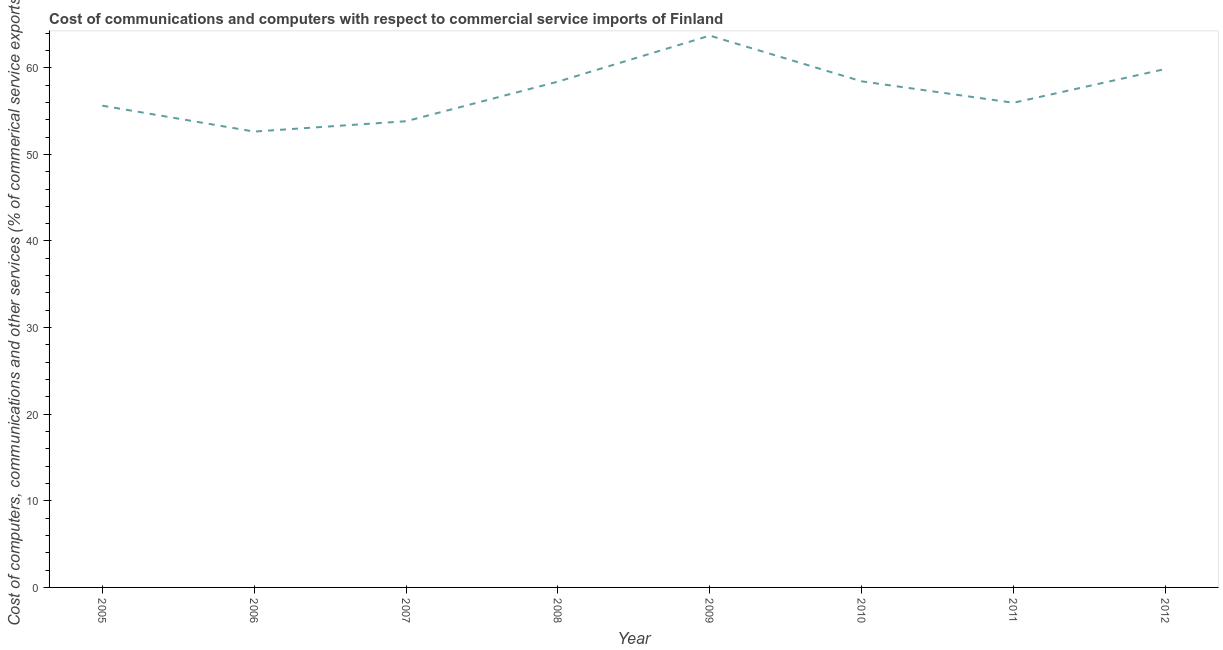What is the  computer and other services in 2006?
Give a very brief answer. 52.63. Across all years, what is the maximum cost of communications?
Keep it short and to the point. 63.71. Across all years, what is the minimum cost of communications?
Ensure brevity in your answer.  52.63. In which year was the cost of communications maximum?
Offer a very short reply. 2009. What is the sum of the  computer and other services?
Provide a short and direct response. 458.43. What is the difference between the  computer and other services in 2007 and 2008?
Provide a short and direct response. -4.57. What is the average  computer and other services per year?
Your answer should be very brief. 57.3. What is the median cost of communications?
Your answer should be very brief. 57.18. Do a majority of the years between 2011 and 2008 (inclusive) have cost of communications greater than 56 %?
Provide a succinct answer. Yes. What is the ratio of the cost of communications in 2006 to that in 2012?
Offer a very short reply. 0.88. Is the cost of communications in 2005 less than that in 2009?
Provide a succinct answer. Yes. Is the difference between the  computer and other services in 2008 and 2009 greater than the difference between any two years?
Provide a succinct answer. No. What is the difference between the highest and the second highest cost of communications?
Keep it short and to the point. 3.85. What is the difference between the highest and the lowest  computer and other services?
Your response must be concise. 11.08. Does the cost of communications monotonically increase over the years?
Your answer should be compact. No. What is the title of the graph?
Ensure brevity in your answer.  Cost of communications and computers with respect to commercial service imports of Finland. What is the label or title of the Y-axis?
Provide a succinct answer. Cost of computers, communications and other services (% of commerical service exports). What is the Cost of computers, communications and other services (% of commerical service exports) in 2005?
Provide a short and direct response. 55.62. What is the Cost of computers, communications and other services (% of commerical service exports) in 2006?
Your response must be concise. 52.63. What is the Cost of computers, communications and other services (% of commerical service exports) of 2007?
Provide a succinct answer. 53.83. What is the Cost of computers, communications and other services (% of commerical service exports) of 2008?
Provide a short and direct response. 58.4. What is the Cost of computers, communications and other services (% of commerical service exports) of 2009?
Keep it short and to the point. 63.71. What is the Cost of computers, communications and other services (% of commerical service exports) of 2010?
Keep it short and to the point. 58.43. What is the Cost of computers, communications and other services (% of commerical service exports) of 2011?
Provide a short and direct response. 55.96. What is the Cost of computers, communications and other services (% of commerical service exports) in 2012?
Provide a succinct answer. 59.86. What is the difference between the Cost of computers, communications and other services (% of commerical service exports) in 2005 and 2006?
Ensure brevity in your answer.  2.99. What is the difference between the Cost of computers, communications and other services (% of commerical service exports) in 2005 and 2007?
Give a very brief answer. 1.8. What is the difference between the Cost of computers, communications and other services (% of commerical service exports) in 2005 and 2008?
Your answer should be compact. -2.77. What is the difference between the Cost of computers, communications and other services (% of commerical service exports) in 2005 and 2009?
Provide a succinct answer. -8.09. What is the difference between the Cost of computers, communications and other services (% of commerical service exports) in 2005 and 2010?
Ensure brevity in your answer.  -2.81. What is the difference between the Cost of computers, communications and other services (% of commerical service exports) in 2005 and 2011?
Keep it short and to the point. -0.33. What is the difference between the Cost of computers, communications and other services (% of commerical service exports) in 2005 and 2012?
Provide a short and direct response. -4.23. What is the difference between the Cost of computers, communications and other services (% of commerical service exports) in 2006 and 2007?
Offer a terse response. -1.19. What is the difference between the Cost of computers, communications and other services (% of commerical service exports) in 2006 and 2008?
Provide a succinct answer. -5.76. What is the difference between the Cost of computers, communications and other services (% of commerical service exports) in 2006 and 2009?
Ensure brevity in your answer.  -11.08. What is the difference between the Cost of computers, communications and other services (% of commerical service exports) in 2006 and 2010?
Your response must be concise. -5.8. What is the difference between the Cost of computers, communications and other services (% of commerical service exports) in 2006 and 2011?
Make the answer very short. -3.32. What is the difference between the Cost of computers, communications and other services (% of commerical service exports) in 2006 and 2012?
Keep it short and to the point. -7.22. What is the difference between the Cost of computers, communications and other services (% of commerical service exports) in 2007 and 2008?
Provide a short and direct response. -4.57. What is the difference between the Cost of computers, communications and other services (% of commerical service exports) in 2007 and 2009?
Give a very brief answer. -9.88. What is the difference between the Cost of computers, communications and other services (% of commerical service exports) in 2007 and 2010?
Give a very brief answer. -4.61. What is the difference between the Cost of computers, communications and other services (% of commerical service exports) in 2007 and 2011?
Offer a terse response. -2.13. What is the difference between the Cost of computers, communications and other services (% of commerical service exports) in 2007 and 2012?
Make the answer very short. -6.03. What is the difference between the Cost of computers, communications and other services (% of commerical service exports) in 2008 and 2009?
Your answer should be very brief. -5.31. What is the difference between the Cost of computers, communications and other services (% of commerical service exports) in 2008 and 2010?
Your response must be concise. -0.04. What is the difference between the Cost of computers, communications and other services (% of commerical service exports) in 2008 and 2011?
Provide a succinct answer. 2.44. What is the difference between the Cost of computers, communications and other services (% of commerical service exports) in 2008 and 2012?
Your answer should be compact. -1.46. What is the difference between the Cost of computers, communications and other services (% of commerical service exports) in 2009 and 2010?
Keep it short and to the point. 5.28. What is the difference between the Cost of computers, communications and other services (% of commerical service exports) in 2009 and 2011?
Keep it short and to the point. 7.75. What is the difference between the Cost of computers, communications and other services (% of commerical service exports) in 2009 and 2012?
Keep it short and to the point. 3.85. What is the difference between the Cost of computers, communications and other services (% of commerical service exports) in 2010 and 2011?
Your answer should be compact. 2.48. What is the difference between the Cost of computers, communications and other services (% of commerical service exports) in 2010 and 2012?
Ensure brevity in your answer.  -1.42. What is the difference between the Cost of computers, communications and other services (% of commerical service exports) in 2011 and 2012?
Give a very brief answer. -3.9. What is the ratio of the Cost of computers, communications and other services (% of commerical service exports) in 2005 to that in 2006?
Offer a terse response. 1.06. What is the ratio of the Cost of computers, communications and other services (% of commerical service exports) in 2005 to that in 2007?
Make the answer very short. 1.03. What is the ratio of the Cost of computers, communications and other services (% of commerical service exports) in 2005 to that in 2008?
Ensure brevity in your answer.  0.95. What is the ratio of the Cost of computers, communications and other services (% of commerical service exports) in 2005 to that in 2009?
Offer a terse response. 0.87. What is the ratio of the Cost of computers, communications and other services (% of commerical service exports) in 2005 to that in 2010?
Provide a succinct answer. 0.95. What is the ratio of the Cost of computers, communications and other services (% of commerical service exports) in 2005 to that in 2011?
Give a very brief answer. 0.99. What is the ratio of the Cost of computers, communications and other services (% of commerical service exports) in 2005 to that in 2012?
Make the answer very short. 0.93. What is the ratio of the Cost of computers, communications and other services (% of commerical service exports) in 2006 to that in 2007?
Your answer should be very brief. 0.98. What is the ratio of the Cost of computers, communications and other services (% of commerical service exports) in 2006 to that in 2008?
Give a very brief answer. 0.9. What is the ratio of the Cost of computers, communications and other services (% of commerical service exports) in 2006 to that in 2009?
Your answer should be compact. 0.83. What is the ratio of the Cost of computers, communications and other services (% of commerical service exports) in 2006 to that in 2010?
Your answer should be compact. 0.9. What is the ratio of the Cost of computers, communications and other services (% of commerical service exports) in 2006 to that in 2011?
Your answer should be very brief. 0.94. What is the ratio of the Cost of computers, communications and other services (% of commerical service exports) in 2006 to that in 2012?
Offer a very short reply. 0.88. What is the ratio of the Cost of computers, communications and other services (% of commerical service exports) in 2007 to that in 2008?
Offer a terse response. 0.92. What is the ratio of the Cost of computers, communications and other services (% of commerical service exports) in 2007 to that in 2009?
Offer a very short reply. 0.84. What is the ratio of the Cost of computers, communications and other services (% of commerical service exports) in 2007 to that in 2010?
Keep it short and to the point. 0.92. What is the ratio of the Cost of computers, communications and other services (% of commerical service exports) in 2007 to that in 2012?
Ensure brevity in your answer.  0.9. What is the ratio of the Cost of computers, communications and other services (% of commerical service exports) in 2008 to that in 2009?
Keep it short and to the point. 0.92. What is the ratio of the Cost of computers, communications and other services (% of commerical service exports) in 2008 to that in 2010?
Keep it short and to the point. 1. What is the ratio of the Cost of computers, communications and other services (% of commerical service exports) in 2008 to that in 2011?
Give a very brief answer. 1.04. What is the ratio of the Cost of computers, communications and other services (% of commerical service exports) in 2008 to that in 2012?
Your answer should be compact. 0.98. What is the ratio of the Cost of computers, communications and other services (% of commerical service exports) in 2009 to that in 2010?
Your answer should be very brief. 1.09. What is the ratio of the Cost of computers, communications and other services (% of commerical service exports) in 2009 to that in 2011?
Offer a terse response. 1.14. What is the ratio of the Cost of computers, communications and other services (% of commerical service exports) in 2009 to that in 2012?
Your answer should be very brief. 1.06. What is the ratio of the Cost of computers, communications and other services (% of commerical service exports) in 2010 to that in 2011?
Ensure brevity in your answer.  1.04. What is the ratio of the Cost of computers, communications and other services (% of commerical service exports) in 2010 to that in 2012?
Ensure brevity in your answer.  0.98. What is the ratio of the Cost of computers, communications and other services (% of commerical service exports) in 2011 to that in 2012?
Give a very brief answer. 0.94. 